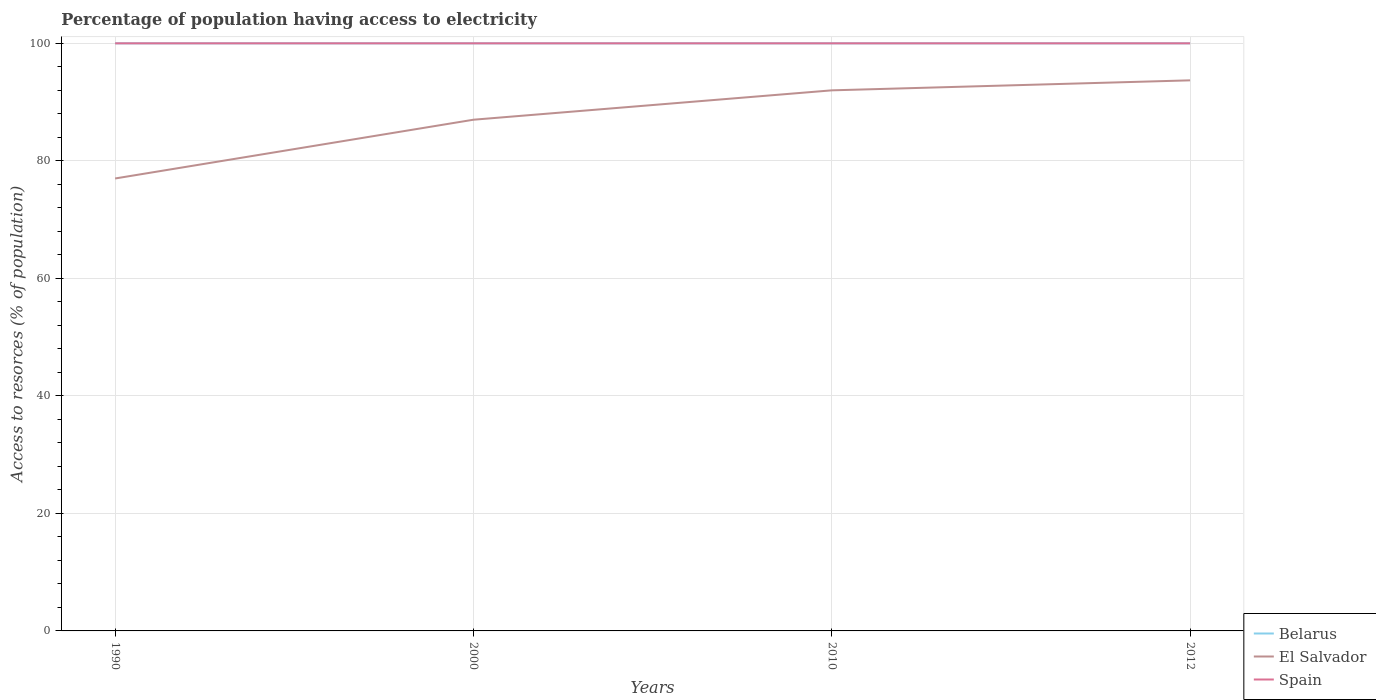How many different coloured lines are there?
Give a very brief answer. 3. Does the line corresponding to Belarus intersect with the line corresponding to El Salvador?
Give a very brief answer. No. Across all years, what is the maximum percentage of population having access to electricity in Belarus?
Your answer should be compact. 100. Is the percentage of population having access to electricity in El Salvador strictly greater than the percentage of population having access to electricity in Belarus over the years?
Ensure brevity in your answer.  Yes. How many lines are there?
Provide a short and direct response. 3. How many years are there in the graph?
Give a very brief answer. 4. Does the graph contain any zero values?
Offer a terse response. No. Where does the legend appear in the graph?
Provide a succinct answer. Bottom right. How many legend labels are there?
Give a very brief answer. 3. How are the legend labels stacked?
Offer a very short reply. Vertical. What is the title of the graph?
Make the answer very short. Percentage of population having access to electricity. What is the label or title of the X-axis?
Offer a terse response. Years. What is the label or title of the Y-axis?
Your answer should be very brief. Access to resorces (% of population). What is the Access to resorces (% of population) of Belarus in 1990?
Offer a very short reply. 100. What is the Access to resorces (% of population) of El Salvador in 1990?
Give a very brief answer. 77. What is the Access to resorces (% of population) in El Salvador in 2000?
Offer a terse response. 87. What is the Access to resorces (% of population) in Belarus in 2010?
Keep it short and to the point. 100. What is the Access to resorces (% of population) of El Salvador in 2010?
Make the answer very short. 92. What is the Access to resorces (% of population) of Belarus in 2012?
Offer a very short reply. 100. What is the Access to resorces (% of population) in El Salvador in 2012?
Ensure brevity in your answer.  93.7. Across all years, what is the maximum Access to resorces (% of population) of Belarus?
Provide a succinct answer. 100. Across all years, what is the maximum Access to resorces (% of population) of El Salvador?
Your answer should be very brief. 93.7. Across all years, what is the maximum Access to resorces (% of population) in Spain?
Provide a succinct answer. 100. Across all years, what is the minimum Access to resorces (% of population) in Belarus?
Offer a terse response. 100. Across all years, what is the minimum Access to resorces (% of population) of Spain?
Ensure brevity in your answer.  100. What is the total Access to resorces (% of population) in El Salvador in the graph?
Offer a very short reply. 349.7. What is the difference between the Access to resorces (% of population) of Belarus in 1990 and that in 2000?
Ensure brevity in your answer.  0. What is the difference between the Access to resorces (% of population) in El Salvador in 1990 and that in 2000?
Offer a very short reply. -10. What is the difference between the Access to resorces (% of population) of Spain in 1990 and that in 2000?
Give a very brief answer. 0. What is the difference between the Access to resorces (% of population) of Belarus in 1990 and that in 2010?
Offer a very short reply. 0. What is the difference between the Access to resorces (% of population) in El Salvador in 1990 and that in 2010?
Make the answer very short. -15. What is the difference between the Access to resorces (% of population) of Belarus in 1990 and that in 2012?
Your answer should be very brief. 0. What is the difference between the Access to resorces (% of population) of El Salvador in 1990 and that in 2012?
Offer a very short reply. -16.7. What is the difference between the Access to resorces (% of population) in El Salvador in 2000 and that in 2010?
Offer a very short reply. -5. What is the difference between the Access to resorces (% of population) in Belarus in 2000 and that in 2012?
Offer a terse response. 0. What is the difference between the Access to resorces (% of population) in Belarus in 2010 and that in 2012?
Make the answer very short. 0. What is the difference between the Access to resorces (% of population) in Belarus in 1990 and the Access to resorces (% of population) in El Salvador in 2000?
Make the answer very short. 13. What is the difference between the Access to resorces (% of population) in Belarus in 1990 and the Access to resorces (% of population) in El Salvador in 2012?
Make the answer very short. 6.3. What is the difference between the Access to resorces (% of population) in Belarus in 2000 and the Access to resorces (% of population) in El Salvador in 2010?
Provide a succinct answer. 8. What is the difference between the Access to resorces (% of population) in Belarus in 2000 and the Access to resorces (% of population) in Spain in 2010?
Your answer should be compact. 0. What is the difference between the Access to resorces (% of population) of El Salvador in 2000 and the Access to resorces (% of population) of Spain in 2010?
Your answer should be very brief. -13. What is the difference between the Access to resorces (% of population) in El Salvador in 2000 and the Access to resorces (% of population) in Spain in 2012?
Give a very brief answer. -13. What is the difference between the Access to resorces (% of population) in El Salvador in 2010 and the Access to resorces (% of population) in Spain in 2012?
Offer a very short reply. -8. What is the average Access to resorces (% of population) in Belarus per year?
Your answer should be very brief. 100. What is the average Access to resorces (% of population) of El Salvador per year?
Your response must be concise. 87.42. In the year 1990, what is the difference between the Access to resorces (% of population) in Belarus and Access to resorces (% of population) in El Salvador?
Your answer should be very brief. 23. In the year 2000, what is the difference between the Access to resorces (% of population) of Belarus and Access to resorces (% of population) of El Salvador?
Your answer should be compact. 13. In the year 2000, what is the difference between the Access to resorces (% of population) in Belarus and Access to resorces (% of population) in Spain?
Give a very brief answer. 0. In the year 2000, what is the difference between the Access to resorces (% of population) of El Salvador and Access to resorces (% of population) of Spain?
Offer a terse response. -13. In the year 2012, what is the difference between the Access to resorces (% of population) in Belarus and Access to resorces (% of population) in El Salvador?
Your response must be concise. 6.3. What is the ratio of the Access to resorces (% of population) in El Salvador in 1990 to that in 2000?
Your response must be concise. 0.89. What is the ratio of the Access to resorces (% of population) of Spain in 1990 to that in 2000?
Give a very brief answer. 1. What is the ratio of the Access to resorces (% of population) of Belarus in 1990 to that in 2010?
Ensure brevity in your answer.  1. What is the ratio of the Access to resorces (% of population) in El Salvador in 1990 to that in 2010?
Give a very brief answer. 0.84. What is the ratio of the Access to resorces (% of population) of El Salvador in 1990 to that in 2012?
Give a very brief answer. 0.82. What is the ratio of the Access to resorces (% of population) in El Salvador in 2000 to that in 2010?
Ensure brevity in your answer.  0.95. What is the ratio of the Access to resorces (% of population) of Spain in 2000 to that in 2010?
Your answer should be very brief. 1. What is the ratio of the Access to resorces (% of population) in El Salvador in 2000 to that in 2012?
Provide a short and direct response. 0.93. What is the ratio of the Access to resorces (% of population) in Spain in 2000 to that in 2012?
Ensure brevity in your answer.  1. What is the ratio of the Access to resorces (% of population) in Belarus in 2010 to that in 2012?
Ensure brevity in your answer.  1. What is the ratio of the Access to resorces (% of population) in El Salvador in 2010 to that in 2012?
Offer a very short reply. 0.98. What is the ratio of the Access to resorces (% of population) of Spain in 2010 to that in 2012?
Make the answer very short. 1. What is the difference between the highest and the second highest Access to resorces (% of population) of Spain?
Make the answer very short. 0. What is the difference between the highest and the lowest Access to resorces (% of population) of Belarus?
Offer a terse response. 0. What is the difference between the highest and the lowest Access to resorces (% of population) of El Salvador?
Give a very brief answer. 16.7. What is the difference between the highest and the lowest Access to resorces (% of population) of Spain?
Provide a succinct answer. 0. 